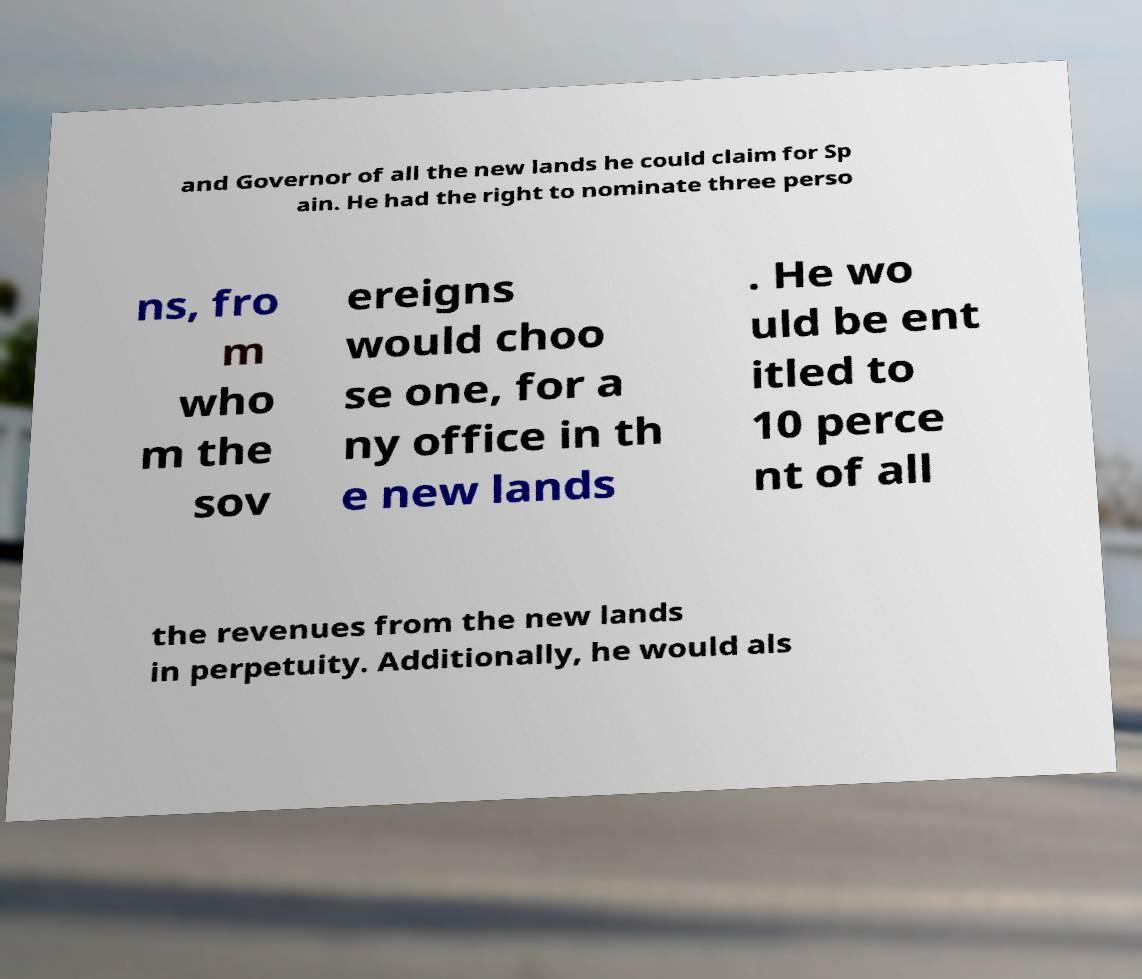There's text embedded in this image that I need extracted. Can you transcribe it verbatim? and Governor of all the new lands he could claim for Sp ain. He had the right to nominate three perso ns, fro m who m the sov ereigns would choo se one, for a ny office in th e new lands . He wo uld be ent itled to 10 perce nt of all the revenues from the new lands in perpetuity. Additionally, he would als 